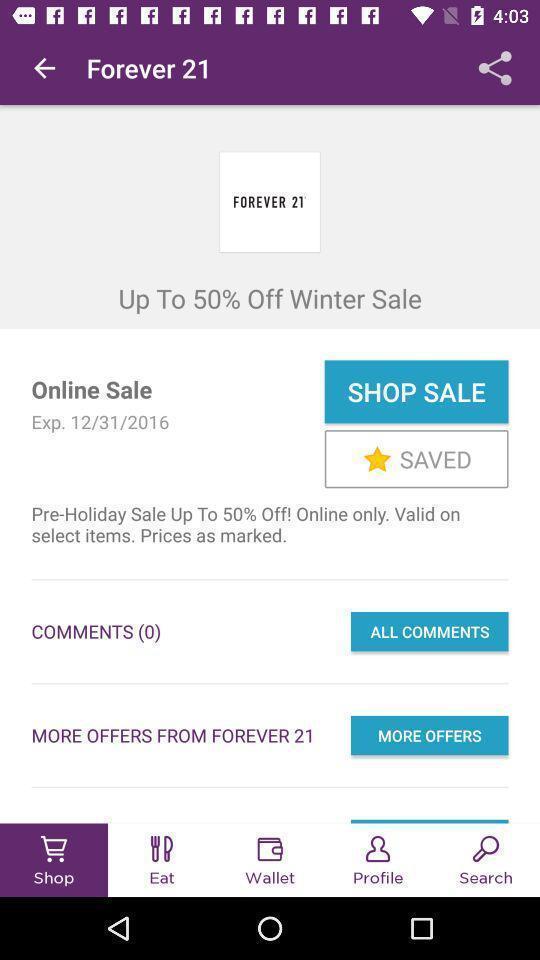Provide a textual representation of this image. Screen shows shop page in online shopping application. 